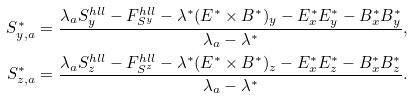Convert formula to latex. <formula><loc_0><loc_0><loc_500><loc_500>S _ { y , a } ^ { * } & = \frac { \lambda _ { a } S _ { y } ^ { h l l } - F _ { S ^ { y } } ^ { h l l } - \lambda ^ { * } ( E ^ { * } \times B ^ { * } ) _ { y } - E ^ { * } _ { x } E ^ { * } _ { y } - B ^ { * } _ { x } B ^ { * } _ { y } } { \lambda _ { a } - \lambda ^ { * } } , \\ S _ { z , a } ^ { * } & = \frac { \lambda _ { a } S _ { z } ^ { h l l } - F _ { S ^ { z } } ^ { h l l } - \lambda ^ { * } ( E ^ { * } \times B ^ { * } ) _ { z } - E ^ { * } _ { x } E ^ { * } _ { z } - B ^ { * } _ { x } B ^ { * } _ { z } } { \lambda _ { a } - \lambda ^ { * } } . \\</formula> 